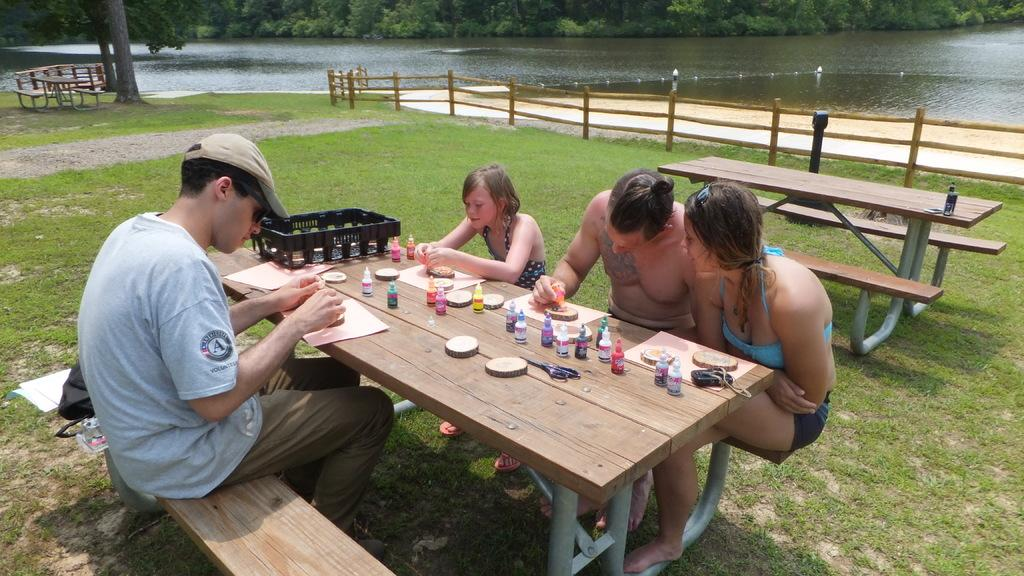How many people are sitting on the bench in the image? There are four people sitting on a bench in the image. What is located near the bench? There is a table in the image. What can be seen on the table? Colors are present on the table, and papers are on the table. What type of natural environment is visible in the image? There is grass and water visible in the image, as well as trees. How many children are standing in line at the border in the image? There are no children or borders present in the image. 